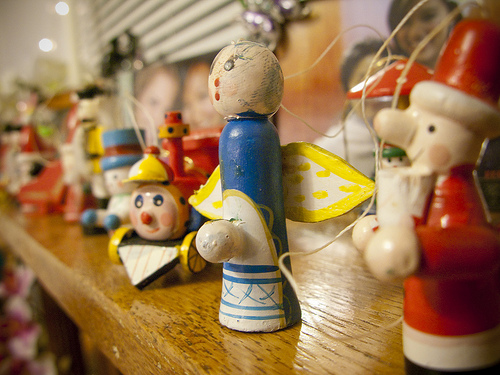<image>
Can you confirm if the toy is above the shelf? No. The toy is not positioned above the shelf. The vertical arrangement shows a different relationship. 